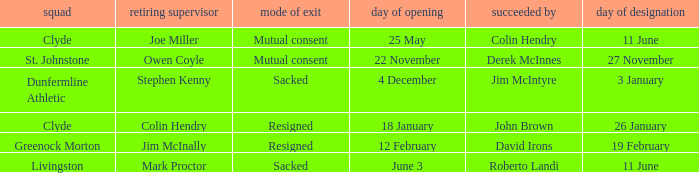Tell me the outgoing manager for livingston Mark Proctor. 